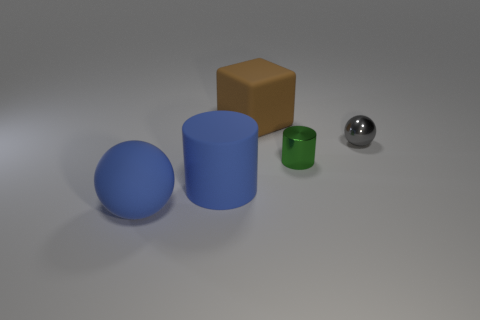There is a ball that is the same color as the large cylinder; what size is it?
Your answer should be very brief. Large. There is a matte thing that is the same color as the big cylinder; what is its shape?
Ensure brevity in your answer.  Sphere. Is there another block that has the same size as the rubber cube?
Keep it short and to the point. No. There is a sphere that is on the right side of the brown rubber object; what number of small gray shiny things are behind it?
Ensure brevity in your answer.  0. What is the material of the small ball?
Keep it short and to the point. Metal. How many objects are on the left side of the small green cylinder?
Ensure brevity in your answer.  3. Is the color of the large cube the same as the tiny metallic ball?
Provide a succinct answer. No. How many spheres are the same color as the rubber cylinder?
Your response must be concise. 1. Is the number of big purple matte cylinders greater than the number of brown objects?
Offer a very short reply. No. There is a object that is both in front of the brown rubber object and behind the small green shiny cylinder; how big is it?
Provide a short and direct response. Small. 